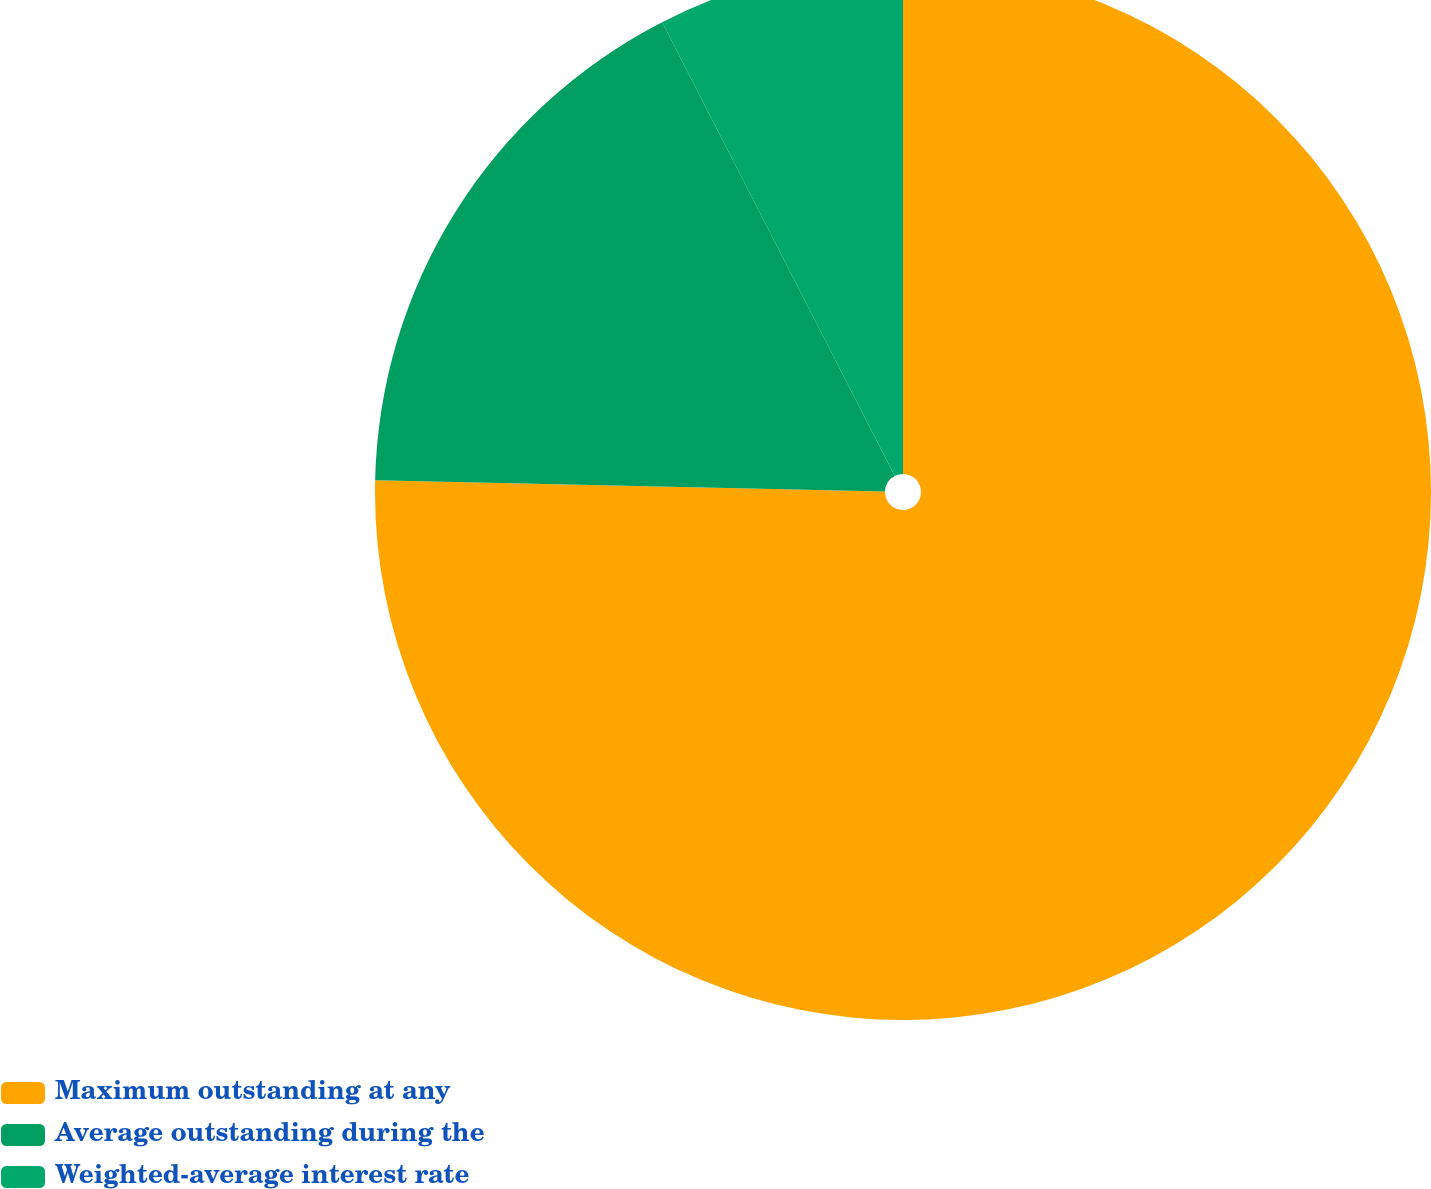<chart> <loc_0><loc_0><loc_500><loc_500><pie_chart><fcel>Maximum outstanding at any<fcel>Average outstanding during the<fcel>Weighted-average interest rate<nl><fcel>75.36%<fcel>17.11%<fcel>7.54%<nl></chart> 